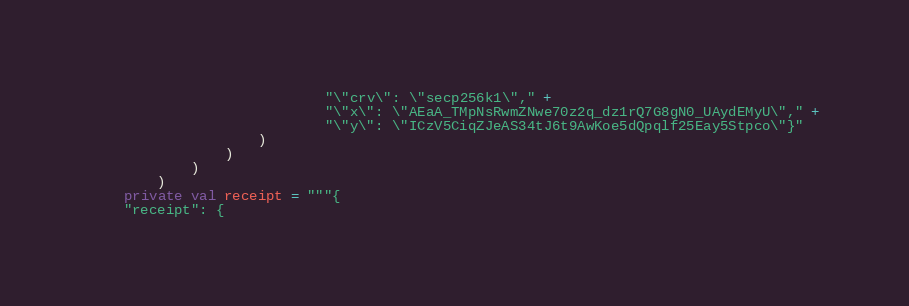<code> <loc_0><loc_0><loc_500><loc_500><_Kotlin_>                            "\"crv\": \"secp256k1\"," +
                            "\"x\": \"AEaA_TMpNsRwmZNwe70z2q_dz1rQ7G8gN0_UAydEMyU\"," +
                            "\"y\": \"ICzV5CiqZJeAS34tJ6t9AwKoe5dQpqlf25Eay5Stpco\"}"
                    )
                )
            )
        )
    private val receipt = """{
    "receipt": {</code> 